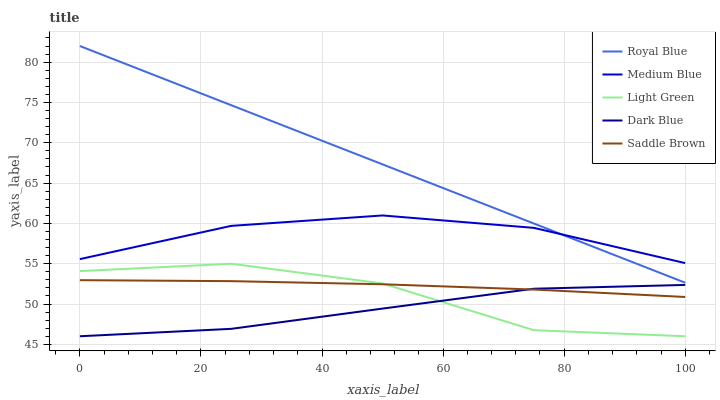Does Medium Blue have the minimum area under the curve?
Answer yes or no. No. Does Medium Blue have the maximum area under the curve?
Answer yes or no. No. Is Medium Blue the smoothest?
Answer yes or no. No. Is Medium Blue the roughest?
Answer yes or no. No. Does Saddle Brown have the lowest value?
Answer yes or no. No. Does Medium Blue have the highest value?
Answer yes or no. No. Is Dark Blue less than Royal Blue?
Answer yes or no. Yes. Is Royal Blue greater than Light Green?
Answer yes or no. Yes. Does Dark Blue intersect Royal Blue?
Answer yes or no. No. 